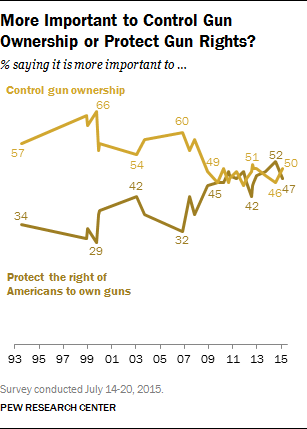What could have caused the shifts in opinions shown in the graph? The shifts in public opinion, as depicted in the graph, could be due to a variety of factors, including political climate, major legislative changes, national events such as mass shootings, and evolving perspectives on personal safety and constitutional rights. Public opinion is often influenced by media coverage and advocacy group campaigns, which can shift the public's focus and priorities over time. 